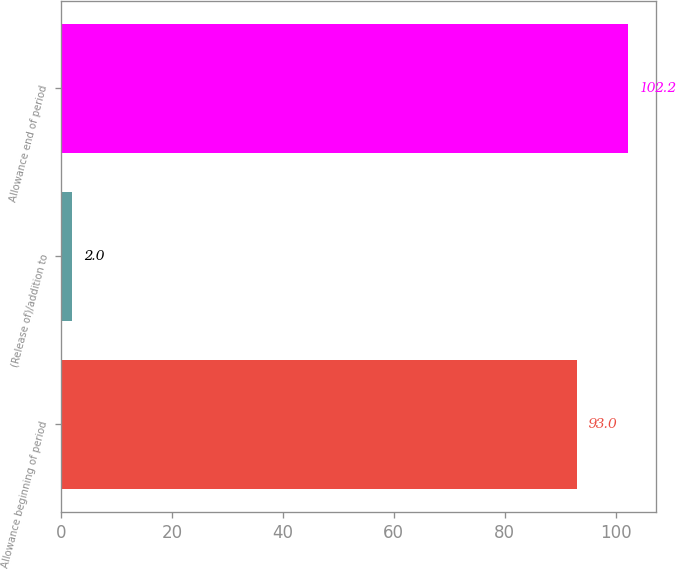Convert chart. <chart><loc_0><loc_0><loc_500><loc_500><bar_chart><fcel>Allowance beginning of period<fcel>(Release of)/addition to<fcel>Allowance end of period<nl><fcel>93<fcel>2<fcel>102.2<nl></chart> 